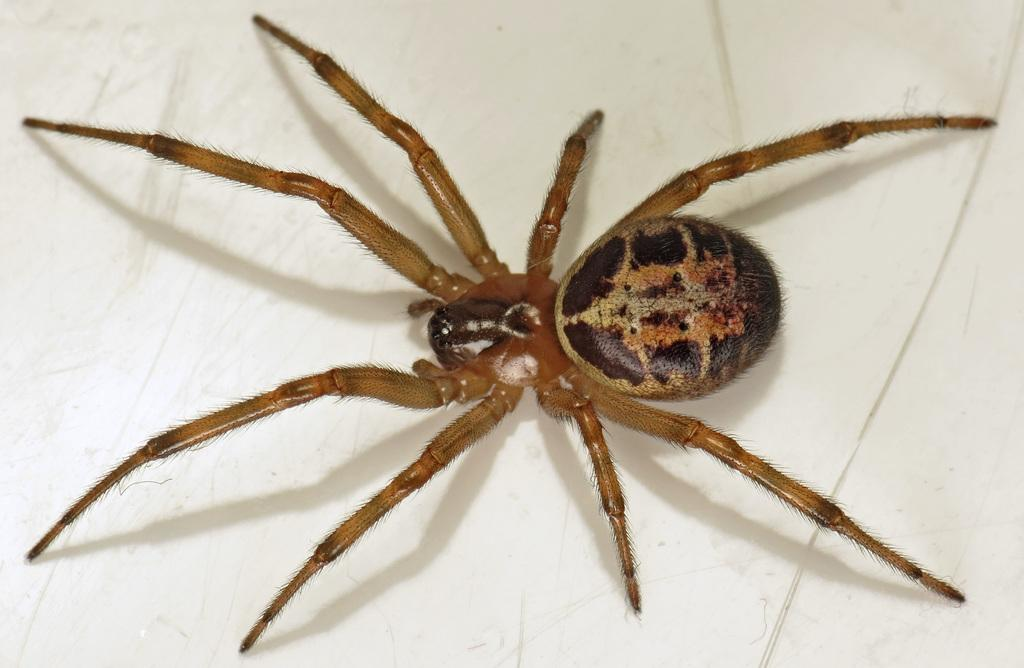What is the main subject of the image? The main subject of the image is a spider. What is the color of the surface on which the spider is located? The spider is on a white surface. What type of zipper can be seen on the spider's back in the image? There is no zipper present on the spider's back in the image. Can you describe the snowy landscape in the background of the image? There is no snow or seashore present in the image; it only features a spider on a white surface. 